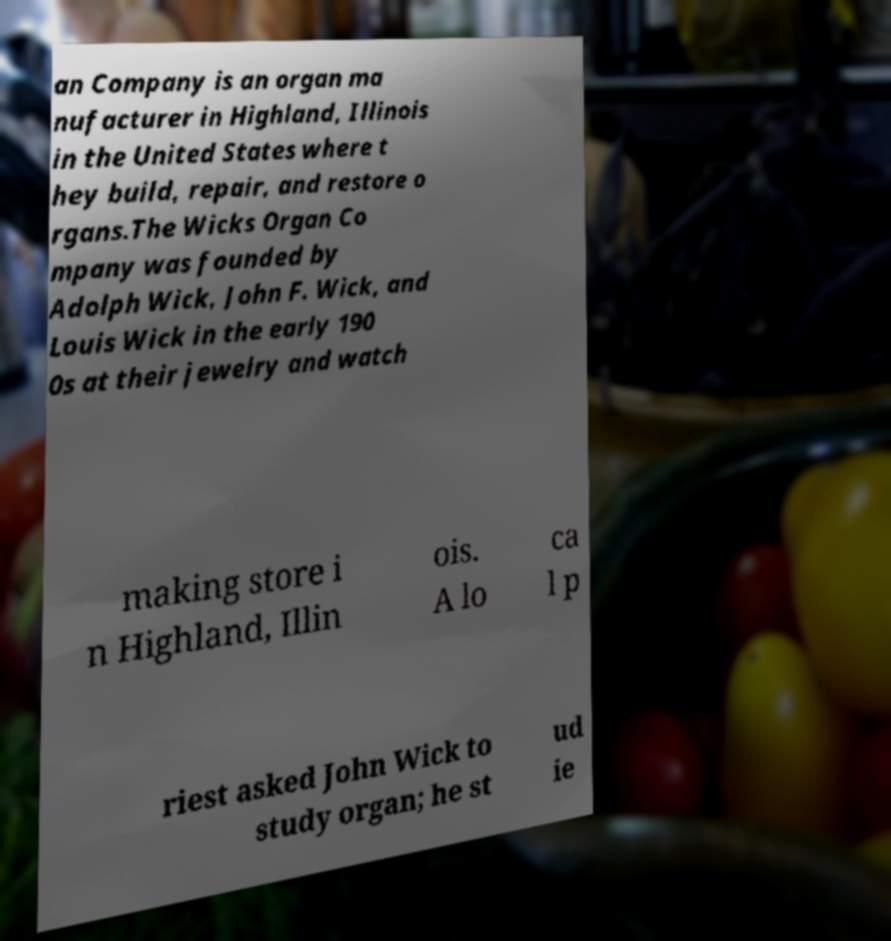Please read and relay the text visible in this image. What does it say? an Company is an organ ma nufacturer in Highland, Illinois in the United States where t hey build, repair, and restore o rgans.The Wicks Organ Co mpany was founded by Adolph Wick, John F. Wick, and Louis Wick in the early 190 0s at their jewelry and watch making store i n Highland, Illin ois. A lo ca l p riest asked John Wick to study organ; he st ud ie 